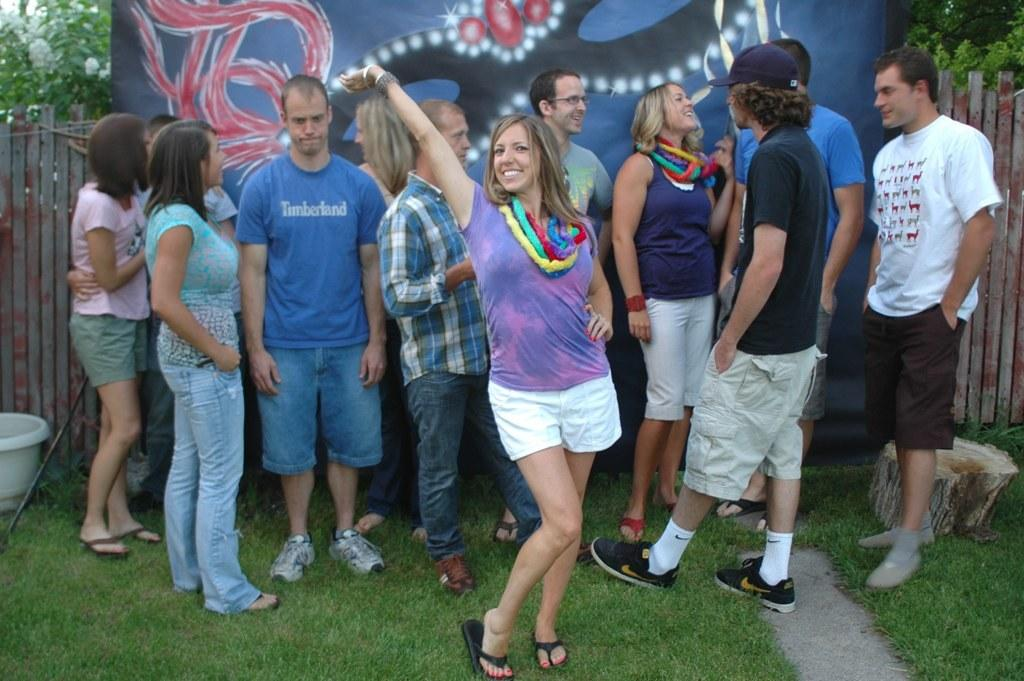What is the main subject of the image? The main subject of the image is a group of people standing on the ground. What can be seen in the background of the image? In the background, there is a banner, a wooden fence, grass, trees, and other unspecified objects. Can you describe the setting of the image? The image appears to be set outdoors, with a grassy area and trees visible in the background. What type of silk is being used for the operation in the image? There is no operation or silk present in the image; it features a group of people standing on the ground with a background of various objects. What kind of toothbrush is visible in the image? There is no toothbrush present in the image. 